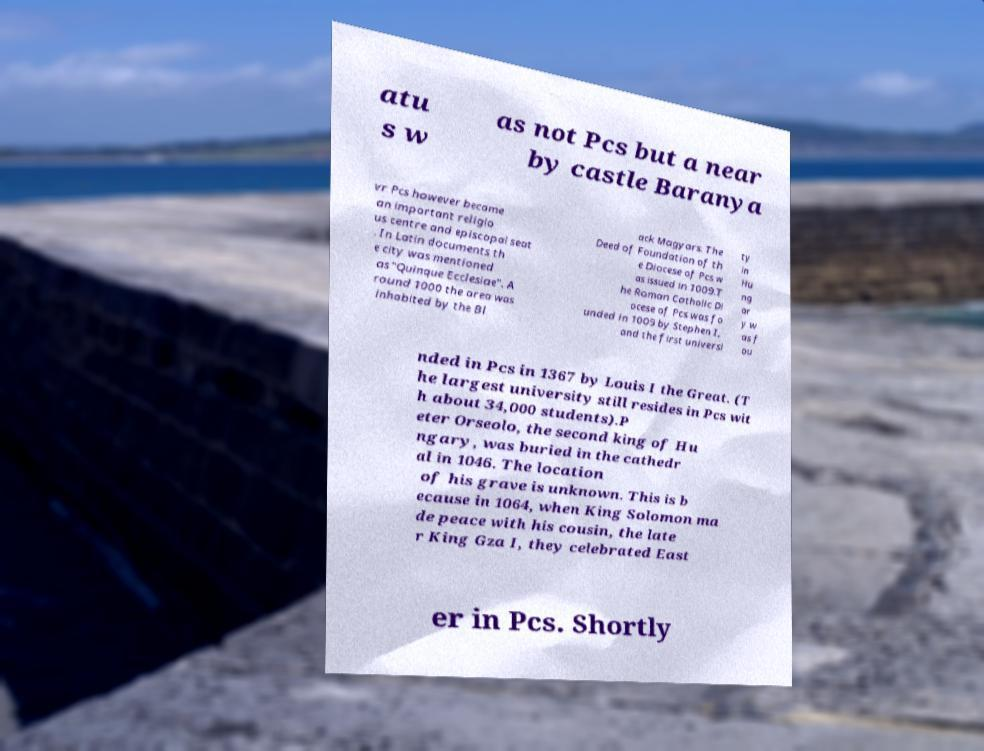Could you assist in decoding the text presented in this image and type it out clearly? atu s w as not Pcs but a near by castle Baranya vr Pcs however became an important religio us centre and episcopal seat . In Latin documents th e city was mentioned as "Quinque Ecclesiae". A round 1000 the area was inhabited by the Bl ack Magyars. The Deed of Foundation of th e Diocese of Pcs w as issued in 1009.T he Roman Catholic Di ocese of Pcs was fo unded in 1009 by Stephen I, and the first universi ty in Hu ng ar y w as f ou nded in Pcs in 1367 by Louis I the Great. (T he largest university still resides in Pcs wit h about 34,000 students).P eter Orseolo, the second king of Hu ngary, was buried in the cathedr al in 1046. The location of his grave is unknown. This is b ecause in 1064, when King Solomon ma de peace with his cousin, the late r King Gza I, they celebrated East er in Pcs. Shortly 